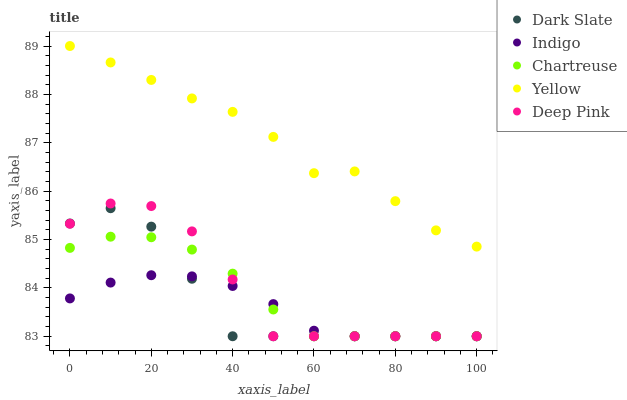Does Indigo have the minimum area under the curve?
Answer yes or no. Yes. Does Yellow have the maximum area under the curve?
Answer yes or no. Yes. Does Chartreuse have the minimum area under the curve?
Answer yes or no. No. Does Chartreuse have the maximum area under the curve?
Answer yes or no. No. Is Indigo the smoothest?
Answer yes or no. Yes. Is Deep Pink the roughest?
Answer yes or no. Yes. Is Chartreuse the smoothest?
Answer yes or no. No. Is Chartreuse the roughest?
Answer yes or no. No. Does Dark Slate have the lowest value?
Answer yes or no. Yes. Does Yellow have the lowest value?
Answer yes or no. No. Does Yellow have the highest value?
Answer yes or no. Yes. Does Chartreuse have the highest value?
Answer yes or no. No. Is Dark Slate less than Yellow?
Answer yes or no. Yes. Is Yellow greater than Chartreuse?
Answer yes or no. Yes. Does Dark Slate intersect Deep Pink?
Answer yes or no. Yes. Is Dark Slate less than Deep Pink?
Answer yes or no. No. Is Dark Slate greater than Deep Pink?
Answer yes or no. No. Does Dark Slate intersect Yellow?
Answer yes or no. No. 